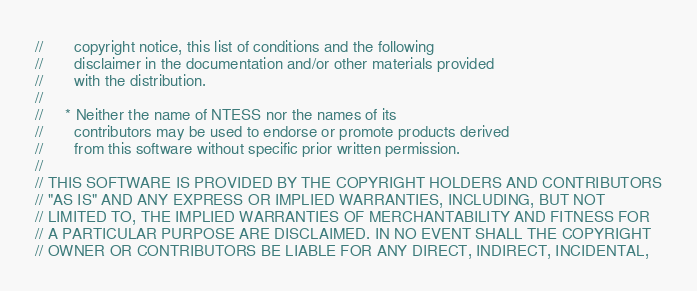<code> <loc_0><loc_0><loc_500><loc_500><_C_>//       copyright notice, this list of conditions and the following
//       disclaimer in the documentation and/or other materials provided
//       with the distribution.
//
//     * Neither the name of NTESS nor the names of its
//       contributors may be used to endorse or promote products derived
//       from this software without specific prior written permission.
//
// THIS SOFTWARE IS PROVIDED BY THE COPYRIGHT HOLDERS AND CONTRIBUTORS
// "AS IS" AND ANY EXPRESS OR IMPLIED WARRANTIES, INCLUDING, BUT NOT
// LIMITED TO, THE IMPLIED WARRANTIES OF MERCHANTABILITY AND FITNESS FOR
// A PARTICULAR PURPOSE ARE DISCLAIMED. IN NO EVENT SHALL THE COPYRIGHT
// OWNER OR CONTRIBUTORS BE LIABLE FOR ANY DIRECT, INDIRECT, INCIDENTAL,</code> 